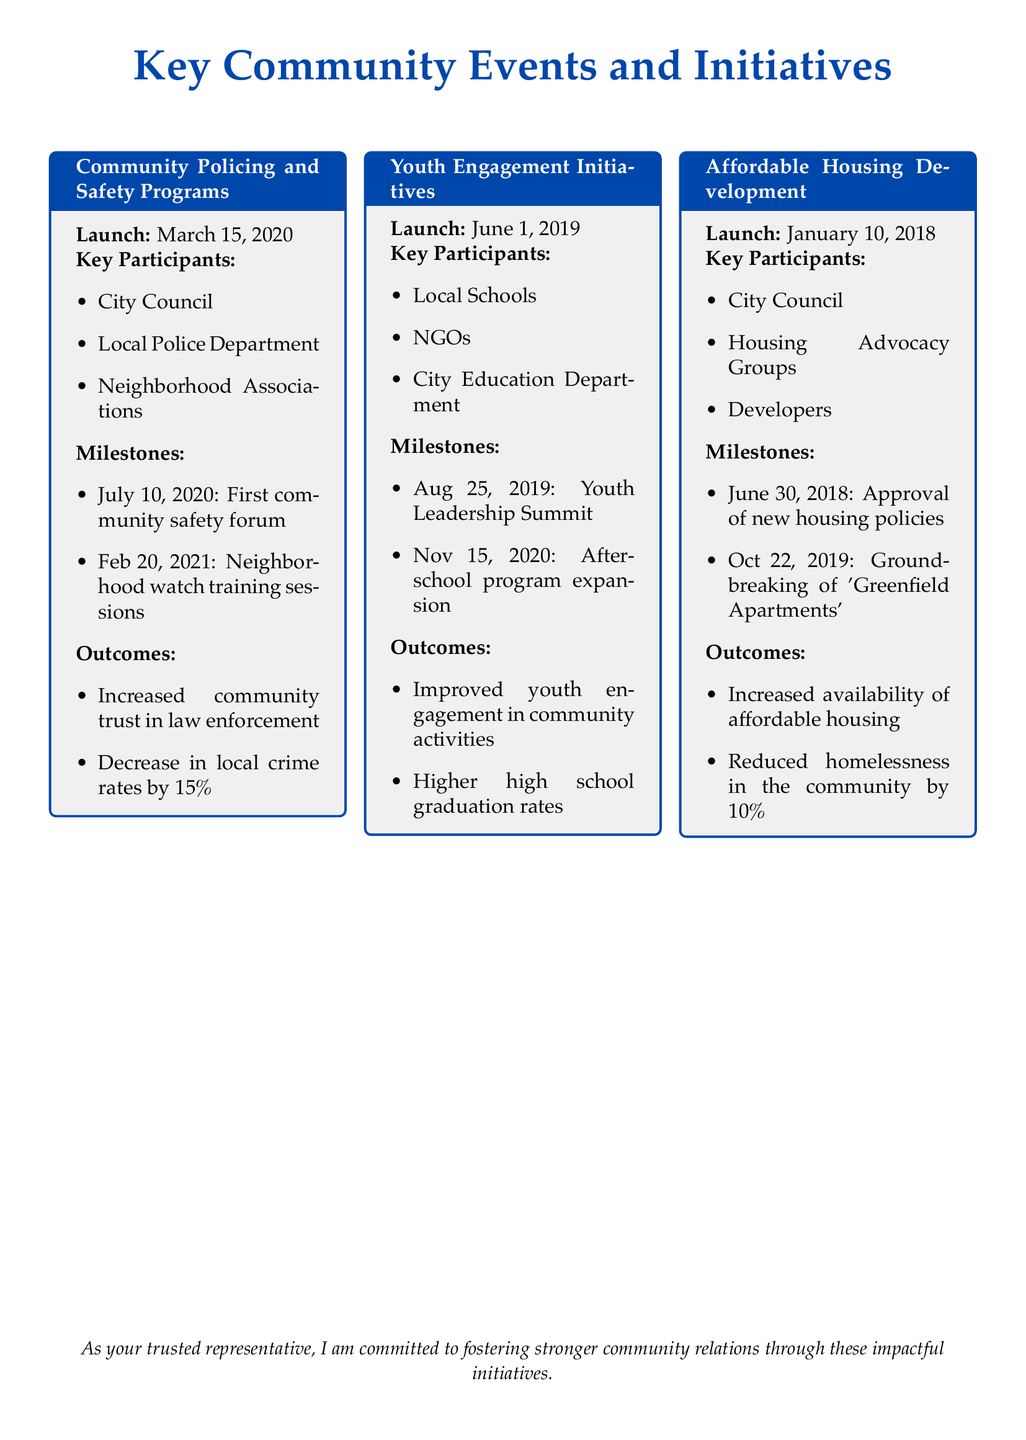What is the launch date of the Community Policing and Safety Programs? The launch date is the date when the Community Policing and Safety Programs began, which is March 15, 2020.
Answer: March 15, 2020 Who are the key participants in the Youth Engagement Initiatives? The key participants are mentioned in the document and include Local Schools, NGOs, and City Education Department.
Answer: Local Schools, NGOs, City Education Department What milestone took place on August 25, 2019, for Youth Engagement Initiatives? The document specifies milestones that occurred, and on August 25, 2019, the Youth Leadership Summit was held.
Answer: Youth Leadership Summit What was the outcome of the Affordable Housing Development in terms of homelessness reduction? The outcome related to homelessness reduction is stated in the document, highlighting a decrease by 10%.
Answer: 10% When was the groundbreaking of 'Greenfield Apartments'? The document provides specific milestones, including the date of the groundbreaking, which is October 22, 2019.
Answer: October 22, 2019 What was the increase in local crime rates due to the Community Policing and Safety Programs? The document indicates the outcome of the programs, outlining a decrease, hence the answer relates to the extent of crime reduction, which is 15%.
Answer: 15% What initiative was launched on June 1, 2019? The document lists different initiatives and confirms that Youth Engagement Initiatives were launched on this date.
Answer: Youth Engagement Initiatives Who approved the new housing policies for Affordable Housing Development? The document identifies the City Council as the approving body for new housing policies mentioned by the participants.
Answer: City Council 